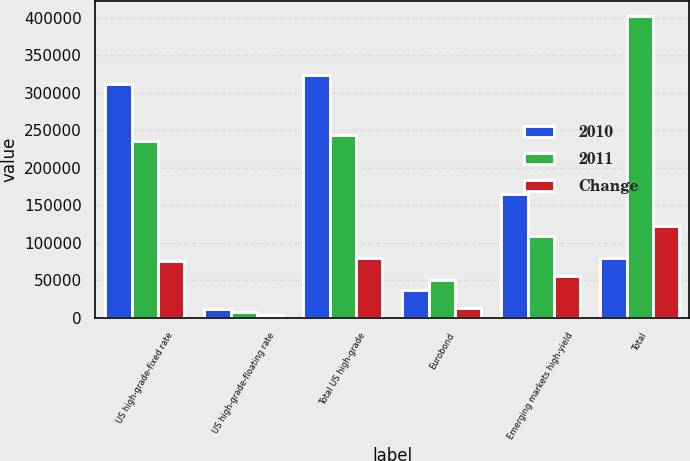Convert chart to OTSL. <chart><loc_0><loc_0><loc_500><loc_500><stacked_bar_chart><ecel><fcel>US high-grade-fixed rate<fcel>US high-grade-floating rate<fcel>Total US high-grade<fcel>Eurobond<fcel>Emerging markets high-yield<fcel>Total<nl><fcel>2010<fcel>311758<fcel>11802<fcel>323560<fcel>36933<fcel>164514<fcel>80164<nl><fcel>2011<fcel>235698<fcel>7698<fcel>243396<fcel>50251<fcel>108610<fcel>402257<nl><fcel>Change<fcel>76060<fcel>4104<fcel>80164<fcel>13318<fcel>55904<fcel>122750<nl></chart> 